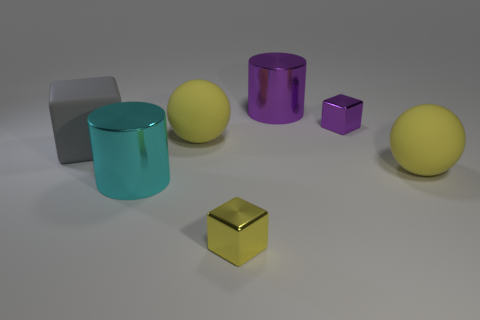Is there a big cylinder of the same color as the large cube?
Make the answer very short. No. There is a cylinder that is behind the cyan thing; is it the same size as the cyan cylinder?
Keep it short and to the point. Yes. Is the number of red metal cylinders less than the number of yellow shiny things?
Your response must be concise. Yes. Are there any other objects that have the same material as the small yellow thing?
Provide a succinct answer. Yes. What is the shape of the large metallic thing behind the rubber cube?
Your answer should be very brief. Cylinder. Is the color of the large ball that is to the left of the large purple object the same as the matte cube?
Give a very brief answer. No. Are there fewer gray matte cubes that are right of the gray rubber object than tiny gray rubber blocks?
Keep it short and to the point. No. There is another block that is made of the same material as the tiny purple cube; what color is it?
Ensure brevity in your answer.  Yellow. How big is the yellow matte sphere that is to the left of the large purple metallic object?
Offer a very short reply. Large. Do the large purple object and the small purple object have the same material?
Provide a short and direct response. Yes. 